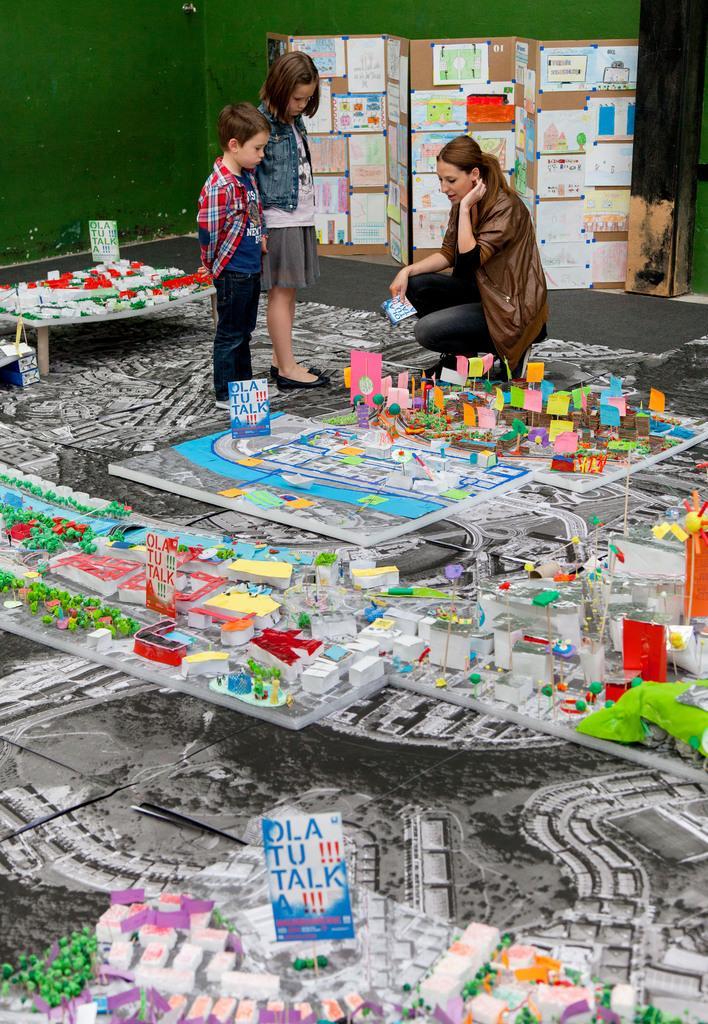How would you summarize this image in a sentence or two? This image is taken indoors. At the bottom of the image there is a floor with many crafts on it. In the middle of the image there is a woman and there are two kids are standing on the floor. In the background there is a wall and there is a board with a few paintings and posters on it. 